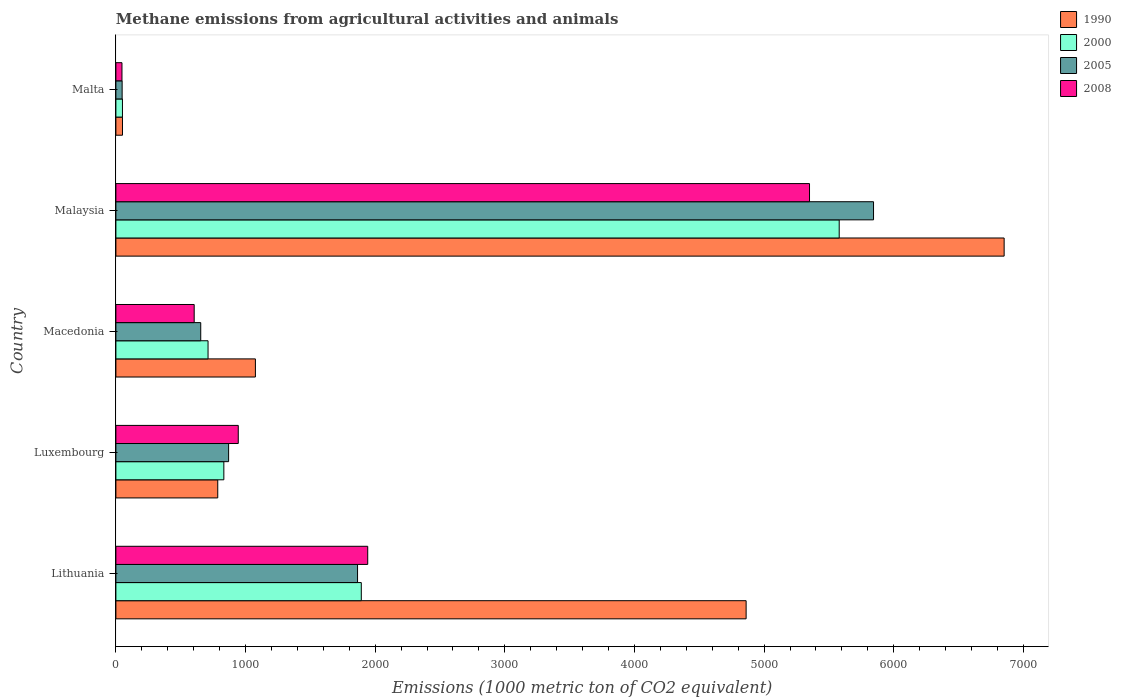How many different coloured bars are there?
Provide a short and direct response. 4. Are the number of bars per tick equal to the number of legend labels?
Give a very brief answer. Yes. Are the number of bars on each tick of the Y-axis equal?
Keep it short and to the point. Yes. How many bars are there on the 1st tick from the top?
Offer a terse response. 4. What is the label of the 5th group of bars from the top?
Your answer should be compact. Lithuania. In how many cases, is the number of bars for a given country not equal to the number of legend labels?
Your answer should be very brief. 0. What is the amount of methane emitted in 2005 in Malaysia?
Make the answer very short. 5844. Across all countries, what is the maximum amount of methane emitted in 2000?
Give a very brief answer. 5579.2. Across all countries, what is the minimum amount of methane emitted in 2005?
Keep it short and to the point. 48.2. In which country was the amount of methane emitted in 2008 maximum?
Your answer should be compact. Malaysia. In which country was the amount of methane emitted in 2000 minimum?
Provide a succinct answer. Malta. What is the total amount of methane emitted in 2008 in the graph?
Your response must be concise. 8887.5. What is the difference between the amount of methane emitted in 2005 in Lithuania and that in Malta?
Offer a terse response. 1815.8. What is the difference between the amount of methane emitted in 2000 in Malaysia and the amount of methane emitted in 1990 in Malta?
Your answer should be compact. 5528.3. What is the average amount of methane emitted in 2000 per country?
Keep it short and to the point. 1813.24. What is the difference between the amount of methane emitted in 2008 and amount of methane emitted in 1990 in Malta?
Your answer should be very brief. -4. What is the ratio of the amount of methane emitted in 1990 in Lithuania to that in Malta?
Provide a succinct answer. 95.51. Is the difference between the amount of methane emitted in 2008 in Lithuania and Macedonia greater than the difference between the amount of methane emitted in 1990 in Lithuania and Macedonia?
Provide a short and direct response. No. What is the difference between the highest and the second highest amount of methane emitted in 2000?
Make the answer very short. 3686.3. What is the difference between the highest and the lowest amount of methane emitted in 2008?
Ensure brevity in your answer.  5303.4. In how many countries, is the amount of methane emitted in 2005 greater than the average amount of methane emitted in 2005 taken over all countries?
Give a very brief answer. 2. What is the difference between two consecutive major ticks on the X-axis?
Make the answer very short. 1000. Does the graph contain any zero values?
Ensure brevity in your answer.  No. Does the graph contain grids?
Give a very brief answer. No. How many legend labels are there?
Offer a terse response. 4. What is the title of the graph?
Offer a terse response. Methane emissions from agricultural activities and animals. What is the label or title of the X-axis?
Provide a succinct answer. Emissions (1000 metric ton of CO2 equivalent). What is the label or title of the Y-axis?
Offer a very short reply. Country. What is the Emissions (1000 metric ton of CO2 equivalent) of 1990 in Lithuania?
Give a very brief answer. 4861.3. What is the Emissions (1000 metric ton of CO2 equivalent) of 2000 in Lithuania?
Make the answer very short. 1892.9. What is the Emissions (1000 metric ton of CO2 equivalent) in 2005 in Lithuania?
Your response must be concise. 1864. What is the Emissions (1000 metric ton of CO2 equivalent) of 2008 in Lithuania?
Keep it short and to the point. 1942.5. What is the Emissions (1000 metric ton of CO2 equivalent) in 1990 in Luxembourg?
Offer a very short reply. 785.7. What is the Emissions (1000 metric ton of CO2 equivalent) of 2000 in Luxembourg?
Keep it short and to the point. 832.7. What is the Emissions (1000 metric ton of CO2 equivalent) of 2005 in Luxembourg?
Give a very brief answer. 869.4. What is the Emissions (1000 metric ton of CO2 equivalent) in 2008 in Luxembourg?
Give a very brief answer. 943.9. What is the Emissions (1000 metric ton of CO2 equivalent) in 1990 in Macedonia?
Your answer should be compact. 1076.2. What is the Emissions (1000 metric ton of CO2 equivalent) in 2000 in Macedonia?
Your answer should be very brief. 710.8. What is the Emissions (1000 metric ton of CO2 equivalent) of 2005 in Macedonia?
Give a very brief answer. 654.4. What is the Emissions (1000 metric ton of CO2 equivalent) in 2008 in Macedonia?
Your answer should be compact. 603.9. What is the Emissions (1000 metric ton of CO2 equivalent) of 1990 in Malaysia?
Give a very brief answer. 6851.5. What is the Emissions (1000 metric ton of CO2 equivalent) of 2000 in Malaysia?
Offer a very short reply. 5579.2. What is the Emissions (1000 metric ton of CO2 equivalent) of 2005 in Malaysia?
Provide a succinct answer. 5844. What is the Emissions (1000 metric ton of CO2 equivalent) in 2008 in Malaysia?
Your answer should be very brief. 5350.3. What is the Emissions (1000 metric ton of CO2 equivalent) in 1990 in Malta?
Keep it short and to the point. 50.9. What is the Emissions (1000 metric ton of CO2 equivalent) of 2000 in Malta?
Make the answer very short. 50.6. What is the Emissions (1000 metric ton of CO2 equivalent) in 2005 in Malta?
Provide a succinct answer. 48.2. What is the Emissions (1000 metric ton of CO2 equivalent) in 2008 in Malta?
Ensure brevity in your answer.  46.9. Across all countries, what is the maximum Emissions (1000 metric ton of CO2 equivalent) in 1990?
Your answer should be very brief. 6851.5. Across all countries, what is the maximum Emissions (1000 metric ton of CO2 equivalent) of 2000?
Make the answer very short. 5579.2. Across all countries, what is the maximum Emissions (1000 metric ton of CO2 equivalent) in 2005?
Offer a very short reply. 5844. Across all countries, what is the maximum Emissions (1000 metric ton of CO2 equivalent) of 2008?
Make the answer very short. 5350.3. Across all countries, what is the minimum Emissions (1000 metric ton of CO2 equivalent) in 1990?
Your response must be concise. 50.9. Across all countries, what is the minimum Emissions (1000 metric ton of CO2 equivalent) of 2000?
Ensure brevity in your answer.  50.6. Across all countries, what is the minimum Emissions (1000 metric ton of CO2 equivalent) of 2005?
Keep it short and to the point. 48.2. Across all countries, what is the minimum Emissions (1000 metric ton of CO2 equivalent) of 2008?
Keep it short and to the point. 46.9. What is the total Emissions (1000 metric ton of CO2 equivalent) in 1990 in the graph?
Your answer should be very brief. 1.36e+04. What is the total Emissions (1000 metric ton of CO2 equivalent) of 2000 in the graph?
Provide a succinct answer. 9066.2. What is the total Emissions (1000 metric ton of CO2 equivalent) in 2005 in the graph?
Give a very brief answer. 9280. What is the total Emissions (1000 metric ton of CO2 equivalent) of 2008 in the graph?
Keep it short and to the point. 8887.5. What is the difference between the Emissions (1000 metric ton of CO2 equivalent) of 1990 in Lithuania and that in Luxembourg?
Your answer should be compact. 4075.6. What is the difference between the Emissions (1000 metric ton of CO2 equivalent) of 2000 in Lithuania and that in Luxembourg?
Give a very brief answer. 1060.2. What is the difference between the Emissions (1000 metric ton of CO2 equivalent) in 2005 in Lithuania and that in Luxembourg?
Offer a terse response. 994.6. What is the difference between the Emissions (1000 metric ton of CO2 equivalent) in 2008 in Lithuania and that in Luxembourg?
Offer a terse response. 998.6. What is the difference between the Emissions (1000 metric ton of CO2 equivalent) in 1990 in Lithuania and that in Macedonia?
Offer a very short reply. 3785.1. What is the difference between the Emissions (1000 metric ton of CO2 equivalent) of 2000 in Lithuania and that in Macedonia?
Provide a succinct answer. 1182.1. What is the difference between the Emissions (1000 metric ton of CO2 equivalent) of 2005 in Lithuania and that in Macedonia?
Offer a terse response. 1209.6. What is the difference between the Emissions (1000 metric ton of CO2 equivalent) of 2008 in Lithuania and that in Macedonia?
Give a very brief answer. 1338.6. What is the difference between the Emissions (1000 metric ton of CO2 equivalent) of 1990 in Lithuania and that in Malaysia?
Your answer should be compact. -1990.2. What is the difference between the Emissions (1000 metric ton of CO2 equivalent) of 2000 in Lithuania and that in Malaysia?
Ensure brevity in your answer.  -3686.3. What is the difference between the Emissions (1000 metric ton of CO2 equivalent) in 2005 in Lithuania and that in Malaysia?
Ensure brevity in your answer.  -3980. What is the difference between the Emissions (1000 metric ton of CO2 equivalent) of 2008 in Lithuania and that in Malaysia?
Your answer should be very brief. -3407.8. What is the difference between the Emissions (1000 metric ton of CO2 equivalent) in 1990 in Lithuania and that in Malta?
Provide a short and direct response. 4810.4. What is the difference between the Emissions (1000 metric ton of CO2 equivalent) of 2000 in Lithuania and that in Malta?
Offer a terse response. 1842.3. What is the difference between the Emissions (1000 metric ton of CO2 equivalent) of 2005 in Lithuania and that in Malta?
Your response must be concise. 1815.8. What is the difference between the Emissions (1000 metric ton of CO2 equivalent) of 2008 in Lithuania and that in Malta?
Keep it short and to the point. 1895.6. What is the difference between the Emissions (1000 metric ton of CO2 equivalent) of 1990 in Luxembourg and that in Macedonia?
Offer a terse response. -290.5. What is the difference between the Emissions (1000 metric ton of CO2 equivalent) of 2000 in Luxembourg and that in Macedonia?
Provide a succinct answer. 121.9. What is the difference between the Emissions (1000 metric ton of CO2 equivalent) in 2005 in Luxembourg and that in Macedonia?
Give a very brief answer. 215. What is the difference between the Emissions (1000 metric ton of CO2 equivalent) in 2008 in Luxembourg and that in Macedonia?
Provide a short and direct response. 340. What is the difference between the Emissions (1000 metric ton of CO2 equivalent) of 1990 in Luxembourg and that in Malaysia?
Your answer should be very brief. -6065.8. What is the difference between the Emissions (1000 metric ton of CO2 equivalent) of 2000 in Luxembourg and that in Malaysia?
Ensure brevity in your answer.  -4746.5. What is the difference between the Emissions (1000 metric ton of CO2 equivalent) of 2005 in Luxembourg and that in Malaysia?
Offer a very short reply. -4974.6. What is the difference between the Emissions (1000 metric ton of CO2 equivalent) of 2008 in Luxembourg and that in Malaysia?
Make the answer very short. -4406.4. What is the difference between the Emissions (1000 metric ton of CO2 equivalent) of 1990 in Luxembourg and that in Malta?
Make the answer very short. 734.8. What is the difference between the Emissions (1000 metric ton of CO2 equivalent) in 2000 in Luxembourg and that in Malta?
Offer a terse response. 782.1. What is the difference between the Emissions (1000 metric ton of CO2 equivalent) of 2005 in Luxembourg and that in Malta?
Your answer should be very brief. 821.2. What is the difference between the Emissions (1000 metric ton of CO2 equivalent) in 2008 in Luxembourg and that in Malta?
Your answer should be compact. 897. What is the difference between the Emissions (1000 metric ton of CO2 equivalent) in 1990 in Macedonia and that in Malaysia?
Your answer should be very brief. -5775.3. What is the difference between the Emissions (1000 metric ton of CO2 equivalent) of 2000 in Macedonia and that in Malaysia?
Provide a short and direct response. -4868.4. What is the difference between the Emissions (1000 metric ton of CO2 equivalent) in 2005 in Macedonia and that in Malaysia?
Your answer should be very brief. -5189.6. What is the difference between the Emissions (1000 metric ton of CO2 equivalent) in 2008 in Macedonia and that in Malaysia?
Your response must be concise. -4746.4. What is the difference between the Emissions (1000 metric ton of CO2 equivalent) of 1990 in Macedonia and that in Malta?
Your answer should be compact. 1025.3. What is the difference between the Emissions (1000 metric ton of CO2 equivalent) in 2000 in Macedonia and that in Malta?
Provide a short and direct response. 660.2. What is the difference between the Emissions (1000 metric ton of CO2 equivalent) in 2005 in Macedonia and that in Malta?
Provide a succinct answer. 606.2. What is the difference between the Emissions (1000 metric ton of CO2 equivalent) in 2008 in Macedonia and that in Malta?
Provide a succinct answer. 557. What is the difference between the Emissions (1000 metric ton of CO2 equivalent) of 1990 in Malaysia and that in Malta?
Give a very brief answer. 6800.6. What is the difference between the Emissions (1000 metric ton of CO2 equivalent) of 2000 in Malaysia and that in Malta?
Your answer should be compact. 5528.6. What is the difference between the Emissions (1000 metric ton of CO2 equivalent) of 2005 in Malaysia and that in Malta?
Offer a terse response. 5795.8. What is the difference between the Emissions (1000 metric ton of CO2 equivalent) of 2008 in Malaysia and that in Malta?
Keep it short and to the point. 5303.4. What is the difference between the Emissions (1000 metric ton of CO2 equivalent) of 1990 in Lithuania and the Emissions (1000 metric ton of CO2 equivalent) of 2000 in Luxembourg?
Ensure brevity in your answer.  4028.6. What is the difference between the Emissions (1000 metric ton of CO2 equivalent) of 1990 in Lithuania and the Emissions (1000 metric ton of CO2 equivalent) of 2005 in Luxembourg?
Offer a very short reply. 3991.9. What is the difference between the Emissions (1000 metric ton of CO2 equivalent) in 1990 in Lithuania and the Emissions (1000 metric ton of CO2 equivalent) in 2008 in Luxembourg?
Your answer should be compact. 3917.4. What is the difference between the Emissions (1000 metric ton of CO2 equivalent) in 2000 in Lithuania and the Emissions (1000 metric ton of CO2 equivalent) in 2005 in Luxembourg?
Give a very brief answer. 1023.5. What is the difference between the Emissions (1000 metric ton of CO2 equivalent) of 2000 in Lithuania and the Emissions (1000 metric ton of CO2 equivalent) of 2008 in Luxembourg?
Give a very brief answer. 949. What is the difference between the Emissions (1000 metric ton of CO2 equivalent) of 2005 in Lithuania and the Emissions (1000 metric ton of CO2 equivalent) of 2008 in Luxembourg?
Give a very brief answer. 920.1. What is the difference between the Emissions (1000 metric ton of CO2 equivalent) of 1990 in Lithuania and the Emissions (1000 metric ton of CO2 equivalent) of 2000 in Macedonia?
Give a very brief answer. 4150.5. What is the difference between the Emissions (1000 metric ton of CO2 equivalent) in 1990 in Lithuania and the Emissions (1000 metric ton of CO2 equivalent) in 2005 in Macedonia?
Your response must be concise. 4206.9. What is the difference between the Emissions (1000 metric ton of CO2 equivalent) in 1990 in Lithuania and the Emissions (1000 metric ton of CO2 equivalent) in 2008 in Macedonia?
Your answer should be very brief. 4257.4. What is the difference between the Emissions (1000 metric ton of CO2 equivalent) in 2000 in Lithuania and the Emissions (1000 metric ton of CO2 equivalent) in 2005 in Macedonia?
Ensure brevity in your answer.  1238.5. What is the difference between the Emissions (1000 metric ton of CO2 equivalent) in 2000 in Lithuania and the Emissions (1000 metric ton of CO2 equivalent) in 2008 in Macedonia?
Provide a succinct answer. 1289. What is the difference between the Emissions (1000 metric ton of CO2 equivalent) in 2005 in Lithuania and the Emissions (1000 metric ton of CO2 equivalent) in 2008 in Macedonia?
Make the answer very short. 1260.1. What is the difference between the Emissions (1000 metric ton of CO2 equivalent) in 1990 in Lithuania and the Emissions (1000 metric ton of CO2 equivalent) in 2000 in Malaysia?
Offer a very short reply. -717.9. What is the difference between the Emissions (1000 metric ton of CO2 equivalent) of 1990 in Lithuania and the Emissions (1000 metric ton of CO2 equivalent) of 2005 in Malaysia?
Make the answer very short. -982.7. What is the difference between the Emissions (1000 metric ton of CO2 equivalent) in 1990 in Lithuania and the Emissions (1000 metric ton of CO2 equivalent) in 2008 in Malaysia?
Offer a very short reply. -489. What is the difference between the Emissions (1000 metric ton of CO2 equivalent) of 2000 in Lithuania and the Emissions (1000 metric ton of CO2 equivalent) of 2005 in Malaysia?
Offer a terse response. -3951.1. What is the difference between the Emissions (1000 metric ton of CO2 equivalent) in 2000 in Lithuania and the Emissions (1000 metric ton of CO2 equivalent) in 2008 in Malaysia?
Your response must be concise. -3457.4. What is the difference between the Emissions (1000 metric ton of CO2 equivalent) of 2005 in Lithuania and the Emissions (1000 metric ton of CO2 equivalent) of 2008 in Malaysia?
Provide a succinct answer. -3486.3. What is the difference between the Emissions (1000 metric ton of CO2 equivalent) of 1990 in Lithuania and the Emissions (1000 metric ton of CO2 equivalent) of 2000 in Malta?
Your answer should be compact. 4810.7. What is the difference between the Emissions (1000 metric ton of CO2 equivalent) in 1990 in Lithuania and the Emissions (1000 metric ton of CO2 equivalent) in 2005 in Malta?
Your response must be concise. 4813.1. What is the difference between the Emissions (1000 metric ton of CO2 equivalent) in 1990 in Lithuania and the Emissions (1000 metric ton of CO2 equivalent) in 2008 in Malta?
Provide a short and direct response. 4814.4. What is the difference between the Emissions (1000 metric ton of CO2 equivalent) of 2000 in Lithuania and the Emissions (1000 metric ton of CO2 equivalent) of 2005 in Malta?
Offer a terse response. 1844.7. What is the difference between the Emissions (1000 metric ton of CO2 equivalent) of 2000 in Lithuania and the Emissions (1000 metric ton of CO2 equivalent) of 2008 in Malta?
Your answer should be very brief. 1846. What is the difference between the Emissions (1000 metric ton of CO2 equivalent) of 2005 in Lithuania and the Emissions (1000 metric ton of CO2 equivalent) of 2008 in Malta?
Your answer should be compact. 1817.1. What is the difference between the Emissions (1000 metric ton of CO2 equivalent) in 1990 in Luxembourg and the Emissions (1000 metric ton of CO2 equivalent) in 2000 in Macedonia?
Give a very brief answer. 74.9. What is the difference between the Emissions (1000 metric ton of CO2 equivalent) of 1990 in Luxembourg and the Emissions (1000 metric ton of CO2 equivalent) of 2005 in Macedonia?
Your answer should be very brief. 131.3. What is the difference between the Emissions (1000 metric ton of CO2 equivalent) in 1990 in Luxembourg and the Emissions (1000 metric ton of CO2 equivalent) in 2008 in Macedonia?
Your answer should be compact. 181.8. What is the difference between the Emissions (1000 metric ton of CO2 equivalent) of 2000 in Luxembourg and the Emissions (1000 metric ton of CO2 equivalent) of 2005 in Macedonia?
Your answer should be very brief. 178.3. What is the difference between the Emissions (1000 metric ton of CO2 equivalent) in 2000 in Luxembourg and the Emissions (1000 metric ton of CO2 equivalent) in 2008 in Macedonia?
Provide a succinct answer. 228.8. What is the difference between the Emissions (1000 metric ton of CO2 equivalent) of 2005 in Luxembourg and the Emissions (1000 metric ton of CO2 equivalent) of 2008 in Macedonia?
Keep it short and to the point. 265.5. What is the difference between the Emissions (1000 metric ton of CO2 equivalent) in 1990 in Luxembourg and the Emissions (1000 metric ton of CO2 equivalent) in 2000 in Malaysia?
Your response must be concise. -4793.5. What is the difference between the Emissions (1000 metric ton of CO2 equivalent) of 1990 in Luxembourg and the Emissions (1000 metric ton of CO2 equivalent) of 2005 in Malaysia?
Your response must be concise. -5058.3. What is the difference between the Emissions (1000 metric ton of CO2 equivalent) of 1990 in Luxembourg and the Emissions (1000 metric ton of CO2 equivalent) of 2008 in Malaysia?
Give a very brief answer. -4564.6. What is the difference between the Emissions (1000 metric ton of CO2 equivalent) of 2000 in Luxembourg and the Emissions (1000 metric ton of CO2 equivalent) of 2005 in Malaysia?
Your response must be concise. -5011.3. What is the difference between the Emissions (1000 metric ton of CO2 equivalent) in 2000 in Luxembourg and the Emissions (1000 metric ton of CO2 equivalent) in 2008 in Malaysia?
Your answer should be compact. -4517.6. What is the difference between the Emissions (1000 metric ton of CO2 equivalent) in 2005 in Luxembourg and the Emissions (1000 metric ton of CO2 equivalent) in 2008 in Malaysia?
Provide a short and direct response. -4480.9. What is the difference between the Emissions (1000 metric ton of CO2 equivalent) in 1990 in Luxembourg and the Emissions (1000 metric ton of CO2 equivalent) in 2000 in Malta?
Offer a terse response. 735.1. What is the difference between the Emissions (1000 metric ton of CO2 equivalent) of 1990 in Luxembourg and the Emissions (1000 metric ton of CO2 equivalent) of 2005 in Malta?
Give a very brief answer. 737.5. What is the difference between the Emissions (1000 metric ton of CO2 equivalent) of 1990 in Luxembourg and the Emissions (1000 metric ton of CO2 equivalent) of 2008 in Malta?
Your response must be concise. 738.8. What is the difference between the Emissions (1000 metric ton of CO2 equivalent) in 2000 in Luxembourg and the Emissions (1000 metric ton of CO2 equivalent) in 2005 in Malta?
Give a very brief answer. 784.5. What is the difference between the Emissions (1000 metric ton of CO2 equivalent) of 2000 in Luxembourg and the Emissions (1000 metric ton of CO2 equivalent) of 2008 in Malta?
Make the answer very short. 785.8. What is the difference between the Emissions (1000 metric ton of CO2 equivalent) in 2005 in Luxembourg and the Emissions (1000 metric ton of CO2 equivalent) in 2008 in Malta?
Offer a very short reply. 822.5. What is the difference between the Emissions (1000 metric ton of CO2 equivalent) in 1990 in Macedonia and the Emissions (1000 metric ton of CO2 equivalent) in 2000 in Malaysia?
Offer a terse response. -4503. What is the difference between the Emissions (1000 metric ton of CO2 equivalent) of 1990 in Macedonia and the Emissions (1000 metric ton of CO2 equivalent) of 2005 in Malaysia?
Your answer should be very brief. -4767.8. What is the difference between the Emissions (1000 metric ton of CO2 equivalent) of 1990 in Macedonia and the Emissions (1000 metric ton of CO2 equivalent) of 2008 in Malaysia?
Keep it short and to the point. -4274.1. What is the difference between the Emissions (1000 metric ton of CO2 equivalent) of 2000 in Macedonia and the Emissions (1000 metric ton of CO2 equivalent) of 2005 in Malaysia?
Offer a very short reply. -5133.2. What is the difference between the Emissions (1000 metric ton of CO2 equivalent) of 2000 in Macedonia and the Emissions (1000 metric ton of CO2 equivalent) of 2008 in Malaysia?
Provide a short and direct response. -4639.5. What is the difference between the Emissions (1000 metric ton of CO2 equivalent) in 2005 in Macedonia and the Emissions (1000 metric ton of CO2 equivalent) in 2008 in Malaysia?
Offer a very short reply. -4695.9. What is the difference between the Emissions (1000 metric ton of CO2 equivalent) in 1990 in Macedonia and the Emissions (1000 metric ton of CO2 equivalent) in 2000 in Malta?
Give a very brief answer. 1025.6. What is the difference between the Emissions (1000 metric ton of CO2 equivalent) of 1990 in Macedonia and the Emissions (1000 metric ton of CO2 equivalent) of 2005 in Malta?
Provide a short and direct response. 1028. What is the difference between the Emissions (1000 metric ton of CO2 equivalent) in 1990 in Macedonia and the Emissions (1000 metric ton of CO2 equivalent) in 2008 in Malta?
Provide a succinct answer. 1029.3. What is the difference between the Emissions (1000 metric ton of CO2 equivalent) of 2000 in Macedonia and the Emissions (1000 metric ton of CO2 equivalent) of 2005 in Malta?
Ensure brevity in your answer.  662.6. What is the difference between the Emissions (1000 metric ton of CO2 equivalent) of 2000 in Macedonia and the Emissions (1000 metric ton of CO2 equivalent) of 2008 in Malta?
Provide a succinct answer. 663.9. What is the difference between the Emissions (1000 metric ton of CO2 equivalent) in 2005 in Macedonia and the Emissions (1000 metric ton of CO2 equivalent) in 2008 in Malta?
Your response must be concise. 607.5. What is the difference between the Emissions (1000 metric ton of CO2 equivalent) in 1990 in Malaysia and the Emissions (1000 metric ton of CO2 equivalent) in 2000 in Malta?
Make the answer very short. 6800.9. What is the difference between the Emissions (1000 metric ton of CO2 equivalent) of 1990 in Malaysia and the Emissions (1000 metric ton of CO2 equivalent) of 2005 in Malta?
Your response must be concise. 6803.3. What is the difference between the Emissions (1000 metric ton of CO2 equivalent) in 1990 in Malaysia and the Emissions (1000 metric ton of CO2 equivalent) in 2008 in Malta?
Offer a terse response. 6804.6. What is the difference between the Emissions (1000 metric ton of CO2 equivalent) of 2000 in Malaysia and the Emissions (1000 metric ton of CO2 equivalent) of 2005 in Malta?
Offer a very short reply. 5531. What is the difference between the Emissions (1000 metric ton of CO2 equivalent) of 2000 in Malaysia and the Emissions (1000 metric ton of CO2 equivalent) of 2008 in Malta?
Keep it short and to the point. 5532.3. What is the difference between the Emissions (1000 metric ton of CO2 equivalent) of 2005 in Malaysia and the Emissions (1000 metric ton of CO2 equivalent) of 2008 in Malta?
Offer a terse response. 5797.1. What is the average Emissions (1000 metric ton of CO2 equivalent) of 1990 per country?
Give a very brief answer. 2725.12. What is the average Emissions (1000 metric ton of CO2 equivalent) of 2000 per country?
Your response must be concise. 1813.24. What is the average Emissions (1000 metric ton of CO2 equivalent) in 2005 per country?
Offer a terse response. 1856. What is the average Emissions (1000 metric ton of CO2 equivalent) in 2008 per country?
Your answer should be compact. 1777.5. What is the difference between the Emissions (1000 metric ton of CO2 equivalent) in 1990 and Emissions (1000 metric ton of CO2 equivalent) in 2000 in Lithuania?
Make the answer very short. 2968.4. What is the difference between the Emissions (1000 metric ton of CO2 equivalent) in 1990 and Emissions (1000 metric ton of CO2 equivalent) in 2005 in Lithuania?
Make the answer very short. 2997.3. What is the difference between the Emissions (1000 metric ton of CO2 equivalent) in 1990 and Emissions (1000 metric ton of CO2 equivalent) in 2008 in Lithuania?
Keep it short and to the point. 2918.8. What is the difference between the Emissions (1000 metric ton of CO2 equivalent) of 2000 and Emissions (1000 metric ton of CO2 equivalent) of 2005 in Lithuania?
Offer a very short reply. 28.9. What is the difference between the Emissions (1000 metric ton of CO2 equivalent) of 2000 and Emissions (1000 metric ton of CO2 equivalent) of 2008 in Lithuania?
Ensure brevity in your answer.  -49.6. What is the difference between the Emissions (1000 metric ton of CO2 equivalent) in 2005 and Emissions (1000 metric ton of CO2 equivalent) in 2008 in Lithuania?
Keep it short and to the point. -78.5. What is the difference between the Emissions (1000 metric ton of CO2 equivalent) of 1990 and Emissions (1000 metric ton of CO2 equivalent) of 2000 in Luxembourg?
Ensure brevity in your answer.  -47. What is the difference between the Emissions (1000 metric ton of CO2 equivalent) in 1990 and Emissions (1000 metric ton of CO2 equivalent) in 2005 in Luxembourg?
Offer a terse response. -83.7. What is the difference between the Emissions (1000 metric ton of CO2 equivalent) in 1990 and Emissions (1000 metric ton of CO2 equivalent) in 2008 in Luxembourg?
Make the answer very short. -158.2. What is the difference between the Emissions (1000 metric ton of CO2 equivalent) in 2000 and Emissions (1000 metric ton of CO2 equivalent) in 2005 in Luxembourg?
Provide a succinct answer. -36.7. What is the difference between the Emissions (1000 metric ton of CO2 equivalent) of 2000 and Emissions (1000 metric ton of CO2 equivalent) of 2008 in Luxembourg?
Provide a succinct answer. -111.2. What is the difference between the Emissions (1000 metric ton of CO2 equivalent) of 2005 and Emissions (1000 metric ton of CO2 equivalent) of 2008 in Luxembourg?
Offer a very short reply. -74.5. What is the difference between the Emissions (1000 metric ton of CO2 equivalent) of 1990 and Emissions (1000 metric ton of CO2 equivalent) of 2000 in Macedonia?
Make the answer very short. 365.4. What is the difference between the Emissions (1000 metric ton of CO2 equivalent) of 1990 and Emissions (1000 metric ton of CO2 equivalent) of 2005 in Macedonia?
Your answer should be very brief. 421.8. What is the difference between the Emissions (1000 metric ton of CO2 equivalent) of 1990 and Emissions (1000 metric ton of CO2 equivalent) of 2008 in Macedonia?
Keep it short and to the point. 472.3. What is the difference between the Emissions (1000 metric ton of CO2 equivalent) in 2000 and Emissions (1000 metric ton of CO2 equivalent) in 2005 in Macedonia?
Keep it short and to the point. 56.4. What is the difference between the Emissions (1000 metric ton of CO2 equivalent) of 2000 and Emissions (1000 metric ton of CO2 equivalent) of 2008 in Macedonia?
Your answer should be very brief. 106.9. What is the difference between the Emissions (1000 metric ton of CO2 equivalent) in 2005 and Emissions (1000 metric ton of CO2 equivalent) in 2008 in Macedonia?
Provide a succinct answer. 50.5. What is the difference between the Emissions (1000 metric ton of CO2 equivalent) of 1990 and Emissions (1000 metric ton of CO2 equivalent) of 2000 in Malaysia?
Your response must be concise. 1272.3. What is the difference between the Emissions (1000 metric ton of CO2 equivalent) of 1990 and Emissions (1000 metric ton of CO2 equivalent) of 2005 in Malaysia?
Give a very brief answer. 1007.5. What is the difference between the Emissions (1000 metric ton of CO2 equivalent) in 1990 and Emissions (1000 metric ton of CO2 equivalent) in 2008 in Malaysia?
Provide a short and direct response. 1501.2. What is the difference between the Emissions (1000 metric ton of CO2 equivalent) of 2000 and Emissions (1000 metric ton of CO2 equivalent) of 2005 in Malaysia?
Make the answer very short. -264.8. What is the difference between the Emissions (1000 metric ton of CO2 equivalent) of 2000 and Emissions (1000 metric ton of CO2 equivalent) of 2008 in Malaysia?
Offer a very short reply. 228.9. What is the difference between the Emissions (1000 metric ton of CO2 equivalent) of 2005 and Emissions (1000 metric ton of CO2 equivalent) of 2008 in Malaysia?
Ensure brevity in your answer.  493.7. What is the difference between the Emissions (1000 metric ton of CO2 equivalent) of 1990 and Emissions (1000 metric ton of CO2 equivalent) of 2000 in Malta?
Your answer should be very brief. 0.3. What is the difference between the Emissions (1000 metric ton of CO2 equivalent) in 1990 and Emissions (1000 metric ton of CO2 equivalent) in 2005 in Malta?
Your response must be concise. 2.7. What is the difference between the Emissions (1000 metric ton of CO2 equivalent) of 2000 and Emissions (1000 metric ton of CO2 equivalent) of 2008 in Malta?
Offer a terse response. 3.7. What is the ratio of the Emissions (1000 metric ton of CO2 equivalent) of 1990 in Lithuania to that in Luxembourg?
Give a very brief answer. 6.19. What is the ratio of the Emissions (1000 metric ton of CO2 equivalent) of 2000 in Lithuania to that in Luxembourg?
Make the answer very short. 2.27. What is the ratio of the Emissions (1000 metric ton of CO2 equivalent) of 2005 in Lithuania to that in Luxembourg?
Provide a short and direct response. 2.14. What is the ratio of the Emissions (1000 metric ton of CO2 equivalent) of 2008 in Lithuania to that in Luxembourg?
Keep it short and to the point. 2.06. What is the ratio of the Emissions (1000 metric ton of CO2 equivalent) in 1990 in Lithuania to that in Macedonia?
Keep it short and to the point. 4.52. What is the ratio of the Emissions (1000 metric ton of CO2 equivalent) in 2000 in Lithuania to that in Macedonia?
Your answer should be very brief. 2.66. What is the ratio of the Emissions (1000 metric ton of CO2 equivalent) of 2005 in Lithuania to that in Macedonia?
Keep it short and to the point. 2.85. What is the ratio of the Emissions (1000 metric ton of CO2 equivalent) of 2008 in Lithuania to that in Macedonia?
Offer a terse response. 3.22. What is the ratio of the Emissions (1000 metric ton of CO2 equivalent) of 1990 in Lithuania to that in Malaysia?
Ensure brevity in your answer.  0.71. What is the ratio of the Emissions (1000 metric ton of CO2 equivalent) of 2000 in Lithuania to that in Malaysia?
Provide a short and direct response. 0.34. What is the ratio of the Emissions (1000 metric ton of CO2 equivalent) in 2005 in Lithuania to that in Malaysia?
Your response must be concise. 0.32. What is the ratio of the Emissions (1000 metric ton of CO2 equivalent) in 2008 in Lithuania to that in Malaysia?
Your answer should be compact. 0.36. What is the ratio of the Emissions (1000 metric ton of CO2 equivalent) of 1990 in Lithuania to that in Malta?
Make the answer very short. 95.51. What is the ratio of the Emissions (1000 metric ton of CO2 equivalent) in 2000 in Lithuania to that in Malta?
Ensure brevity in your answer.  37.41. What is the ratio of the Emissions (1000 metric ton of CO2 equivalent) in 2005 in Lithuania to that in Malta?
Your answer should be very brief. 38.67. What is the ratio of the Emissions (1000 metric ton of CO2 equivalent) in 2008 in Lithuania to that in Malta?
Offer a terse response. 41.42. What is the ratio of the Emissions (1000 metric ton of CO2 equivalent) in 1990 in Luxembourg to that in Macedonia?
Provide a short and direct response. 0.73. What is the ratio of the Emissions (1000 metric ton of CO2 equivalent) in 2000 in Luxembourg to that in Macedonia?
Your answer should be very brief. 1.17. What is the ratio of the Emissions (1000 metric ton of CO2 equivalent) in 2005 in Luxembourg to that in Macedonia?
Offer a very short reply. 1.33. What is the ratio of the Emissions (1000 metric ton of CO2 equivalent) in 2008 in Luxembourg to that in Macedonia?
Provide a succinct answer. 1.56. What is the ratio of the Emissions (1000 metric ton of CO2 equivalent) in 1990 in Luxembourg to that in Malaysia?
Your answer should be compact. 0.11. What is the ratio of the Emissions (1000 metric ton of CO2 equivalent) of 2000 in Luxembourg to that in Malaysia?
Ensure brevity in your answer.  0.15. What is the ratio of the Emissions (1000 metric ton of CO2 equivalent) of 2005 in Luxembourg to that in Malaysia?
Your answer should be compact. 0.15. What is the ratio of the Emissions (1000 metric ton of CO2 equivalent) in 2008 in Luxembourg to that in Malaysia?
Provide a short and direct response. 0.18. What is the ratio of the Emissions (1000 metric ton of CO2 equivalent) of 1990 in Luxembourg to that in Malta?
Make the answer very short. 15.44. What is the ratio of the Emissions (1000 metric ton of CO2 equivalent) of 2000 in Luxembourg to that in Malta?
Your answer should be compact. 16.46. What is the ratio of the Emissions (1000 metric ton of CO2 equivalent) in 2005 in Luxembourg to that in Malta?
Offer a terse response. 18.04. What is the ratio of the Emissions (1000 metric ton of CO2 equivalent) in 2008 in Luxembourg to that in Malta?
Give a very brief answer. 20.13. What is the ratio of the Emissions (1000 metric ton of CO2 equivalent) in 1990 in Macedonia to that in Malaysia?
Offer a terse response. 0.16. What is the ratio of the Emissions (1000 metric ton of CO2 equivalent) of 2000 in Macedonia to that in Malaysia?
Make the answer very short. 0.13. What is the ratio of the Emissions (1000 metric ton of CO2 equivalent) of 2005 in Macedonia to that in Malaysia?
Provide a succinct answer. 0.11. What is the ratio of the Emissions (1000 metric ton of CO2 equivalent) in 2008 in Macedonia to that in Malaysia?
Your response must be concise. 0.11. What is the ratio of the Emissions (1000 metric ton of CO2 equivalent) in 1990 in Macedonia to that in Malta?
Keep it short and to the point. 21.14. What is the ratio of the Emissions (1000 metric ton of CO2 equivalent) in 2000 in Macedonia to that in Malta?
Give a very brief answer. 14.05. What is the ratio of the Emissions (1000 metric ton of CO2 equivalent) in 2005 in Macedonia to that in Malta?
Your answer should be compact. 13.58. What is the ratio of the Emissions (1000 metric ton of CO2 equivalent) of 2008 in Macedonia to that in Malta?
Give a very brief answer. 12.88. What is the ratio of the Emissions (1000 metric ton of CO2 equivalent) in 1990 in Malaysia to that in Malta?
Give a very brief answer. 134.61. What is the ratio of the Emissions (1000 metric ton of CO2 equivalent) in 2000 in Malaysia to that in Malta?
Keep it short and to the point. 110.26. What is the ratio of the Emissions (1000 metric ton of CO2 equivalent) of 2005 in Malaysia to that in Malta?
Offer a very short reply. 121.24. What is the ratio of the Emissions (1000 metric ton of CO2 equivalent) in 2008 in Malaysia to that in Malta?
Your answer should be compact. 114.08. What is the difference between the highest and the second highest Emissions (1000 metric ton of CO2 equivalent) of 1990?
Your answer should be compact. 1990.2. What is the difference between the highest and the second highest Emissions (1000 metric ton of CO2 equivalent) of 2000?
Make the answer very short. 3686.3. What is the difference between the highest and the second highest Emissions (1000 metric ton of CO2 equivalent) in 2005?
Ensure brevity in your answer.  3980. What is the difference between the highest and the second highest Emissions (1000 metric ton of CO2 equivalent) in 2008?
Your response must be concise. 3407.8. What is the difference between the highest and the lowest Emissions (1000 metric ton of CO2 equivalent) of 1990?
Ensure brevity in your answer.  6800.6. What is the difference between the highest and the lowest Emissions (1000 metric ton of CO2 equivalent) of 2000?
Offer a very short reply. 5528.6. What is the difference between the highest and the lowest Emissions (1000 metric ton of CO2 equivalent) of 2005?
Keep it short and to the point. 5795.8. What is the difference between the highest and the lowest Emissions (1000 metric ton of CO2 equivalent) in 2008?
Provide a succinct answer. 5303.4. 